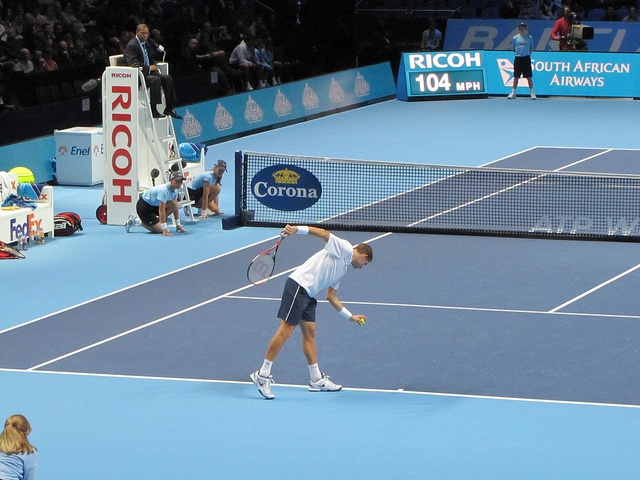Describe the objects in this image and their specific colors. I can see people in black, lightgray, darkgray, and gray tones, people in black, gray, and lightgray tones, people in black, lightblue, tan, and gray tones, bench in black, ivory, darkgray, and gray tones, and people in black, gray, and maroon tones in this image. 